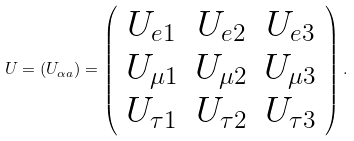<formula> <loc_0><loc_0><loc_500><loc_500>U = ( U _ { \alpha a } ) = \left ( \begin{array} { c c c } U _ { e 1 } & U _ { e 2 } & U _ { e 3 } \\ U _ { \mu 1 } & U _ { \mu 2 } & U _ { \mu 3 } \\ U _ { \tau 1 } & U _ { \tau 2 } & U _ { \tau 3 } \end{array} \right ) .</formula> 